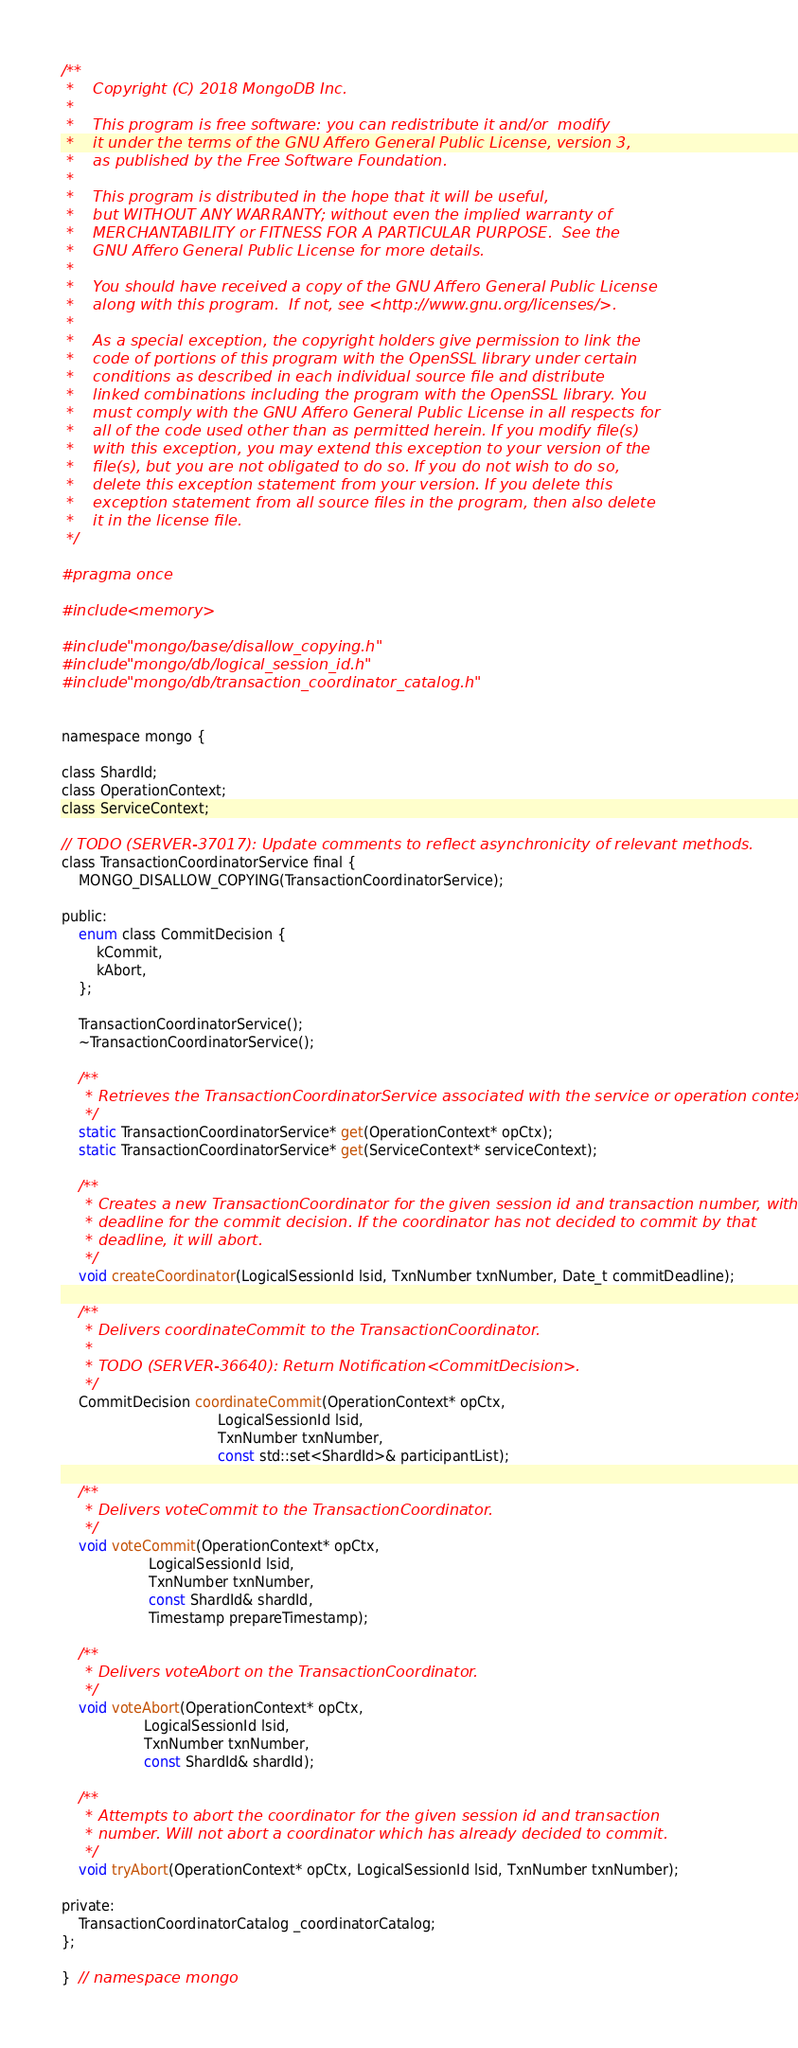<code> <loc_0><loc_0><loc_500><loc_500><_C_>/**
 *    Copyright (C) 2018 MongoDB Inc.
 *
 *    This program is free software: you can redistribute it and/or  modify
 *    it under the terms of the GNU Affero General Public License, version 3,
 *    as published by the Free Software Foundation.
 *
 *    This program is distributed in the hope that it will be useful,
 *    but WITHOUT ANY WARRANTY; without even the implied warranty of
 *    MERCHANTABILITY or FITNESS FOR A PARTICULAR PURPOSE.  See the
 *    GNU Affero General Public License for more details.
 *
 *    You should have received a copy of the GNU Affero General Public License
 *    along with this program.  If not, see <http://www.gnu.org/licenses/>.
 *
 *    As a special exception, the copyright holders give permission to link the
 *    code of portions of this program with the OpenSSL library under certain
 *    conditions as described in each individual source file and distribute
 *    linked combinations including the program with the OpenSSL library. You
 *    must comply with the GNU Affero General Public License in all respects for
 *    all of the code used other than as permitted herein. If you modify file(s)
 *    with this exception, you may extend this exception to your version of the
 *    file(s), but you are not obligated to do so. If you do not wish to do so,
 *    delete this exception statement from your version. If you delete this
 *    exception statement from all source files in the program, then also delete
 *    it in the license file.
 */

#pragma once

#include <memory>

#include "mongo/base/disallow_copying.h"
#include "mongo/db/logical_session_id.h"
#include "mongo/db/transaction_coordinator_catalog.h"


namespace mongo {

class ShardId;
class OperationContext;
class ServiceContext;

// TODO (SERVER-37017): Update comments to reflect asynchronicity of relevant methods.
class TransactionCoordinatorService final {
    MONGO_DISALLOW_COPYING(TransactionCoordinatorService);

public:
    enum class CommitDecision {
        kCommit,
        kAbort,
    };

    TransactionCoordinatorService();
    ~TransactionCoordinatorService();

    /**
     * Retrieves the TransactionCoordinatorService associated with the service or operation context.
     */
    static TransactionCoordinatorService* get(OperationContext* opCtx);
    static TransactionCoordinatorService* get(ServiceContext* serviceContext);

    /**
     * Creates a new TransactionCoordinator for the given session id and transaction number, with a
     * deadline for the commit decision. If the coordinator has not decided to commit by that
     * deadline, it will abort.
     */
    void createCoordinator(LogicalSessionId lsid, TxnNumber txnNumber, Date_t commitDeadline);

    /**
     * Delivers coordinateCommit to the TransactionCoordinator.
     *
     * TODO (SERVER-36640): Return Notification<CommitDecision>.
     */
    CommitDecision coordinateCommit(OperationContext* opCtx,
                                    LogicalSessionId lsid,
                                    TxnNumber txnNumber,
                                    const std::set<ShardId>& participantList);

    /**
     * Delivers voteCommit to the TransactionCoordinator.
     */
    void voteCommit(OperationContext* opCtx,
                    LogicalSessionId lsid,
                    TxnNumber txnNumber,
                    const ShardId& shardId,
                    Timestamp prepareTimestamp);

    /**
     * Delivers voteAbort on the TransactionCoordinator.
     */
    void voteAbort(OperationContext* opCtx,
                   LogicalSessionId lsid,
                   TxnNumber txnNumber,
                   const ShardId& shardId);

    /**
     * Attempts to abort the coordinator for the given session id and transaction
     * number. Will not abort a coordinator which has already decided to commit.
     */
    void tryAbort(OperationContext* opCtx, LogicalSessionId lsid, TxnNumber txnNumber);

private:
    TransactionCoordinatorCatalog _coordinatorCatalog;
};

}  // namespace mongo
</code> 